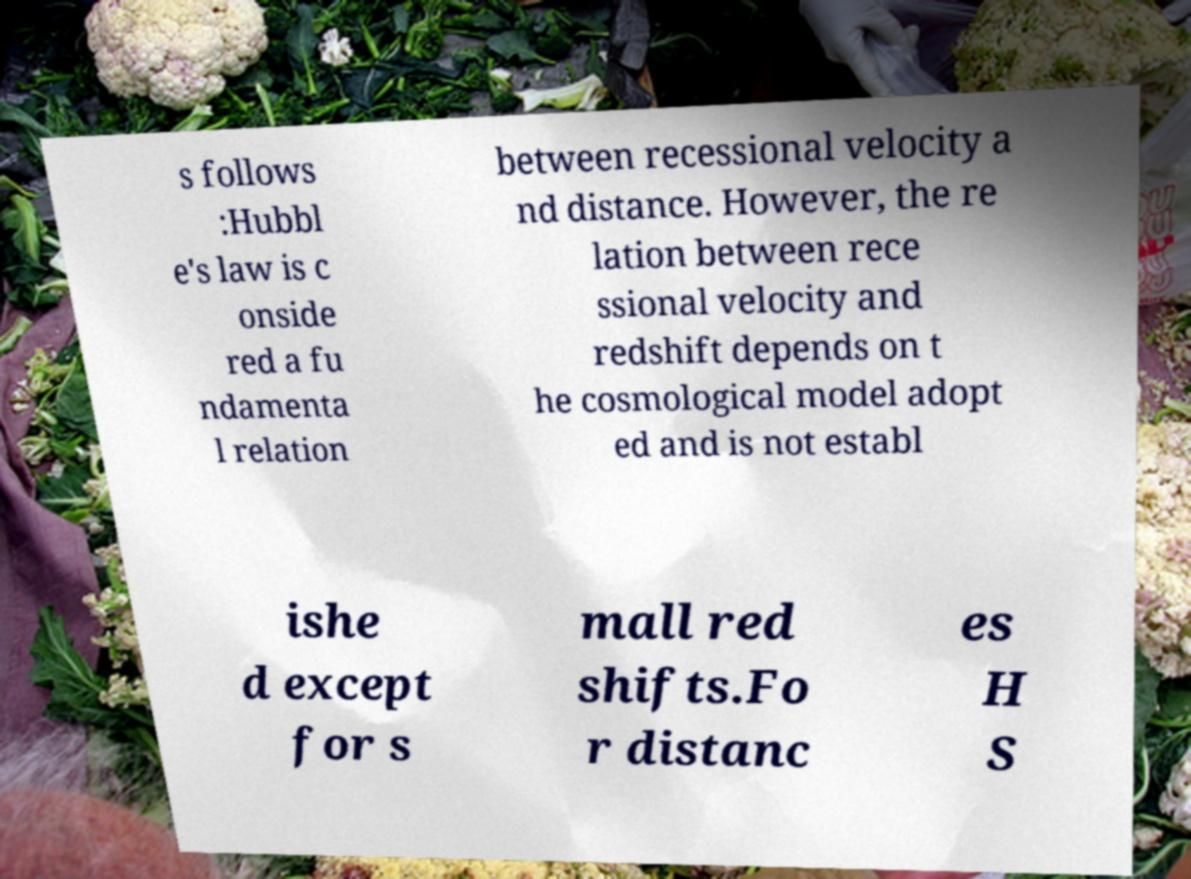There's text embedded in this image that I need extracted. Can you transcribe it verbatim? s follows :Hubbl e's law is c onside red a fu ndamenta l relation between recessional velocity a nd distance. However, the re lation between rece ssional velocity and redshift depends on t he cosmological model adopt ed and is not establ ishe d except for s mall red shifts.Fo r distanc es H S 